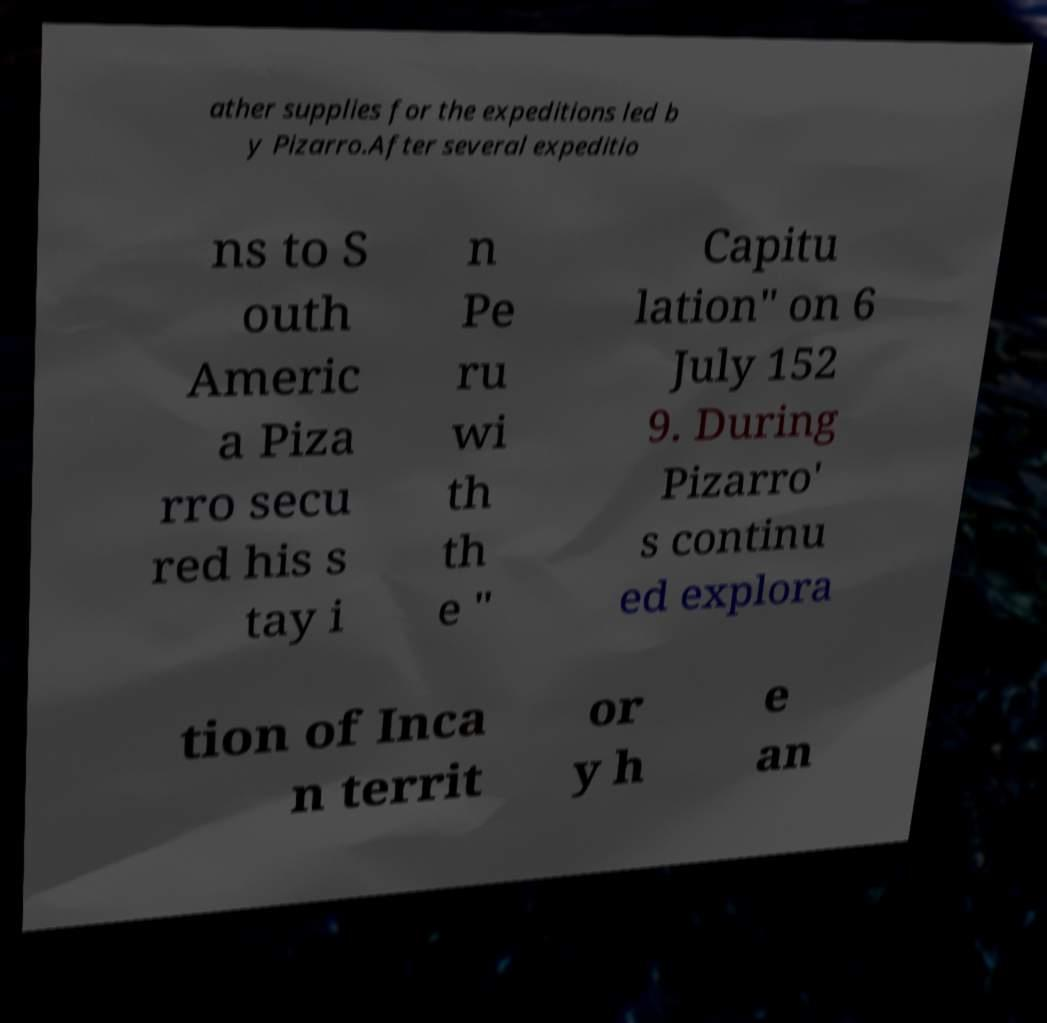What messages or text are displayed in this image? I need them in a readable, typed format. ather supplies for the expeditions led b y Pizarro.After several expeditio ns to S outh Americ a Piza rro secu red his s tay i n Pe ru wi th th e " Capitu lation" on 6 July 152 9. During Pizarro' s continu ed explora tion of Inca n territ or y h e an 